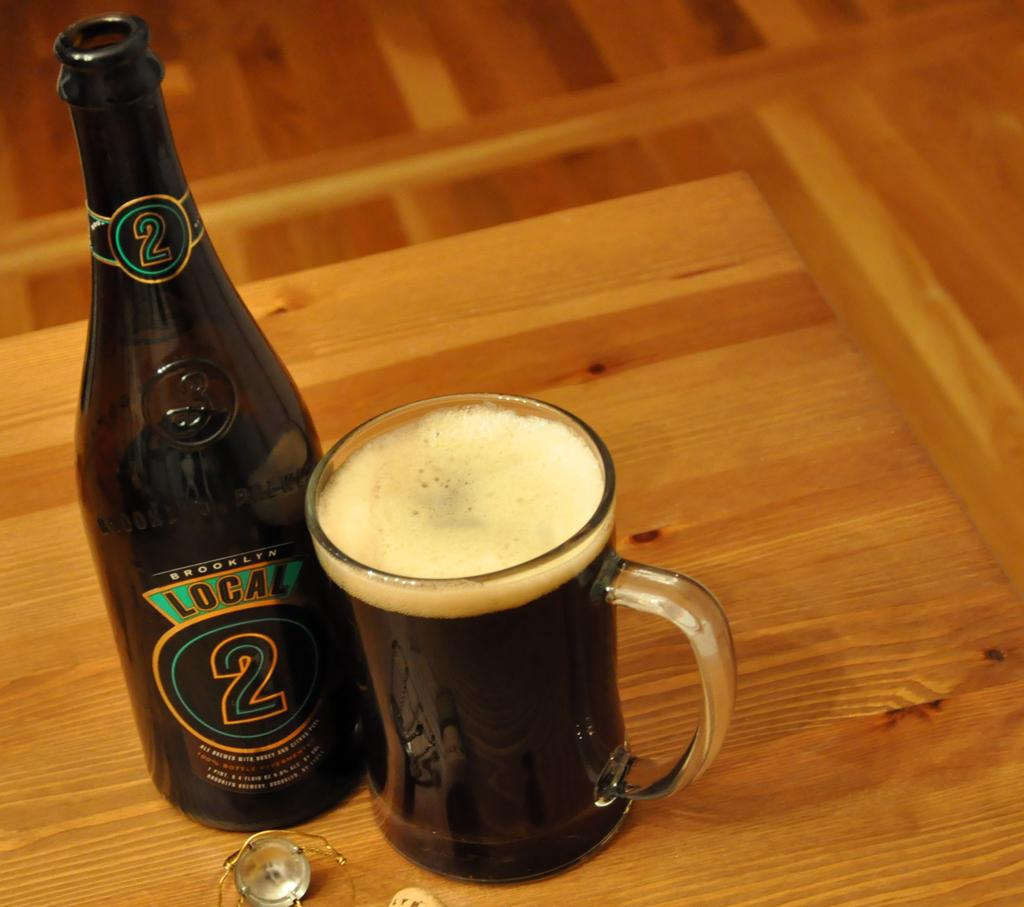<image>
Render a clear and concise summary of the photo. a beer bottle with the number 2 on it 